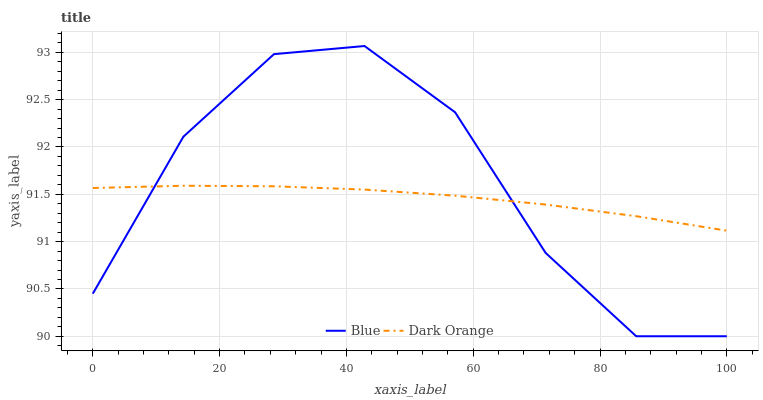Does Dark Orange have the minimum area under the curve?
Answer yes or no. Yes. Does Blue have the maximum area under the curve?
Answer yes or no. Yes. Does Dark Orange have the maximum area under the curve?
Answer yes or no. No. Is Dark Orange the smoothest?
Answer yes or no. Yes. Is Blue the roughest?
Answer yes or no. Yes. Is Dark Orange the roughest?
Answer yes or no. No. Does Blue have the lowest value?
Answer yes or no. Yes. Does Dark Orange have the lowest value?
Answer yes or no. No. Does Blue have the highest value?
Answer yes or no. Yes. Does Dark Orange have the highest value?
Answer yes or no. No. Does Dark Orange intersect Blue?
Answer yes or no. Yes. Is Dark Orange less than Blue?
Answer yes or no. No. Is Dark Orange greater than Blue?
Answer yes or no. No. 